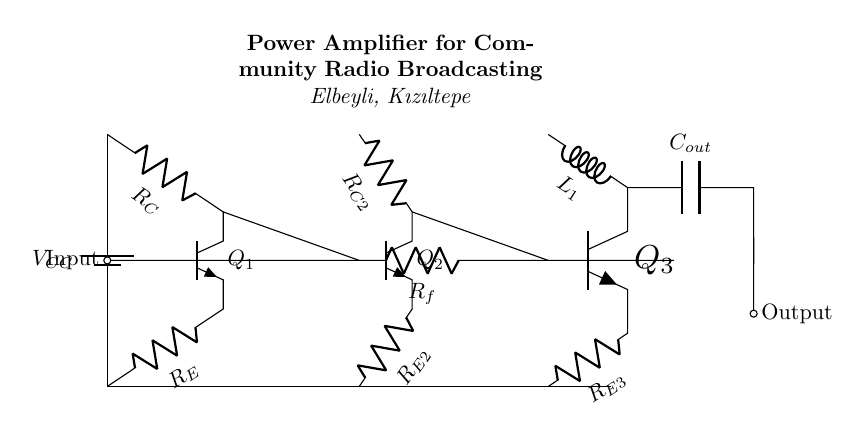What is the main function of the circuit? The main function of the circuit is to amplify audio signals for radio broadcasting, allowing them to be transmitted over a larger area.
Answer: Amplification What type of transistors are used in the circuit? The circuit uses NPN transistors, as indicated by the npn labels next to each transistor symbol.
Answer: NPN How many stages are there in this amplifier circuit? There are three stages in this amplifier circuit: the input stage, driver stage, and output stage.
Answer: Three What is the role of the feedback resistor? The feedback resistor helps to control the gain of the amplifier by providing a feedback path from the output to the input stage, ensuring stability and linearity.
Answer: Gain control What component connects the output stage to the output? The capacitor connected to the collector of the output transistor connects the output stage to the output, allowing AC signals to pass while blocking DC.
Answer: Capacitor What is the purpose of the emitter resistor in the first transistor? The emitter resistor stabilizes the operating point of the first transistor by providing negative feedback, which helps maintain consistent performance regardless of variations in temperature or transistor characteristics.
Answer: Stabilization What is the significance of the inductance in the output stage? The inductance in the output stage helps to smooth the output current and can improve the frequency response of the amplifier, making it suitable for audio signals.
Answer: Frequency response 